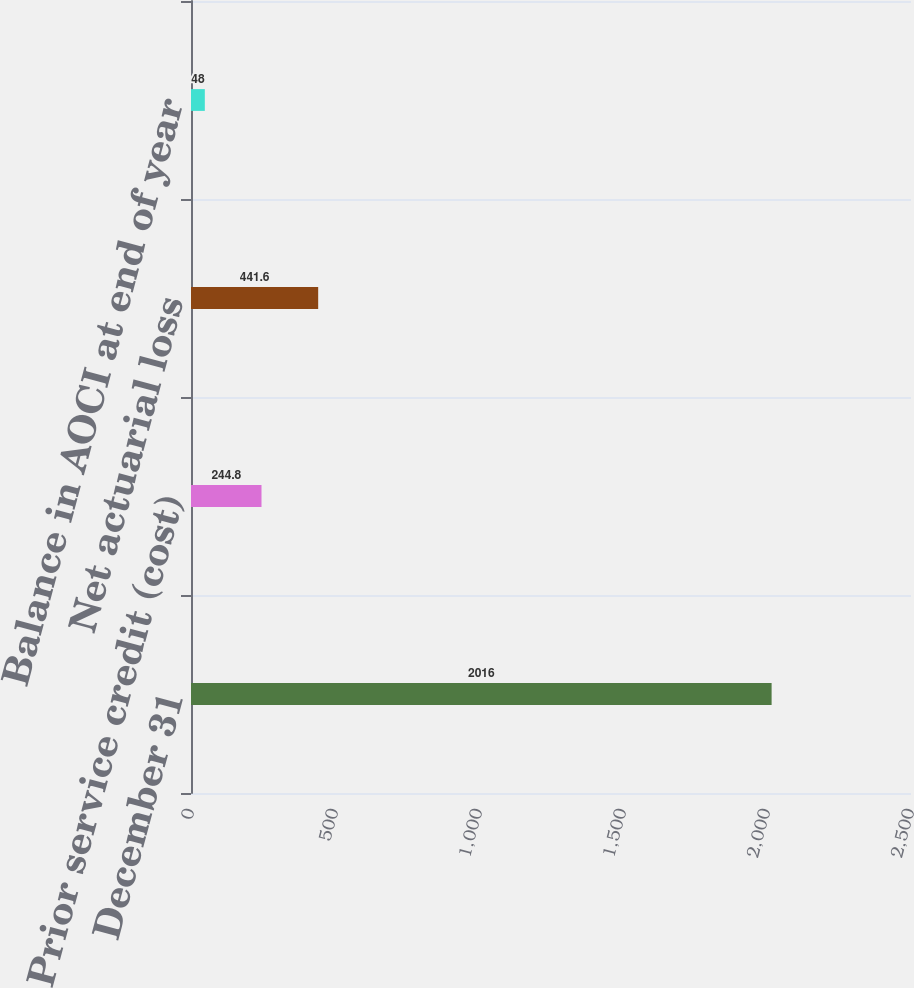<chart> <loc_0><loc_0><loc_500><loc_500><bar_chart><fcel>December 31<fcel>Prior service credit (cost)<fcel>Net actuarial loss<fcel>Balance in AOCI at end of year<nl><fcel>2016<fcel>244.8<fcel>441.6<fcel>48<nl></chart> 